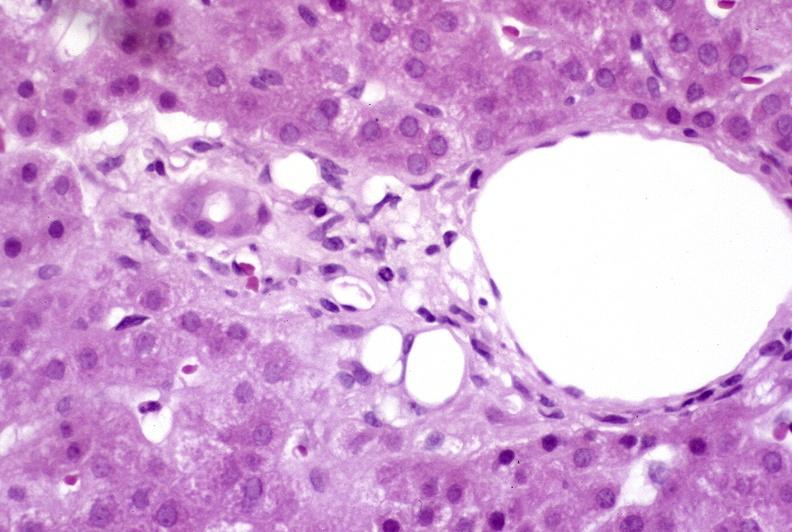what is present?
Answer the question using a single word or phrase. Liver 